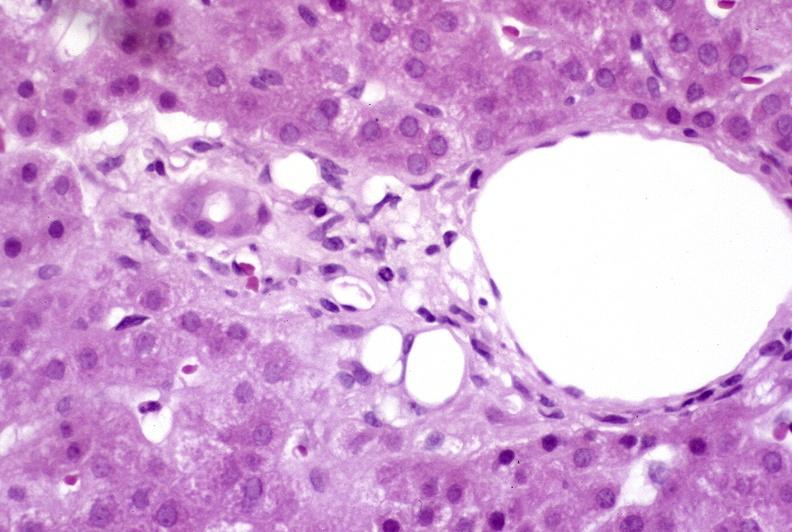what is present?
Answer the question using a single word or phrase. Liver 